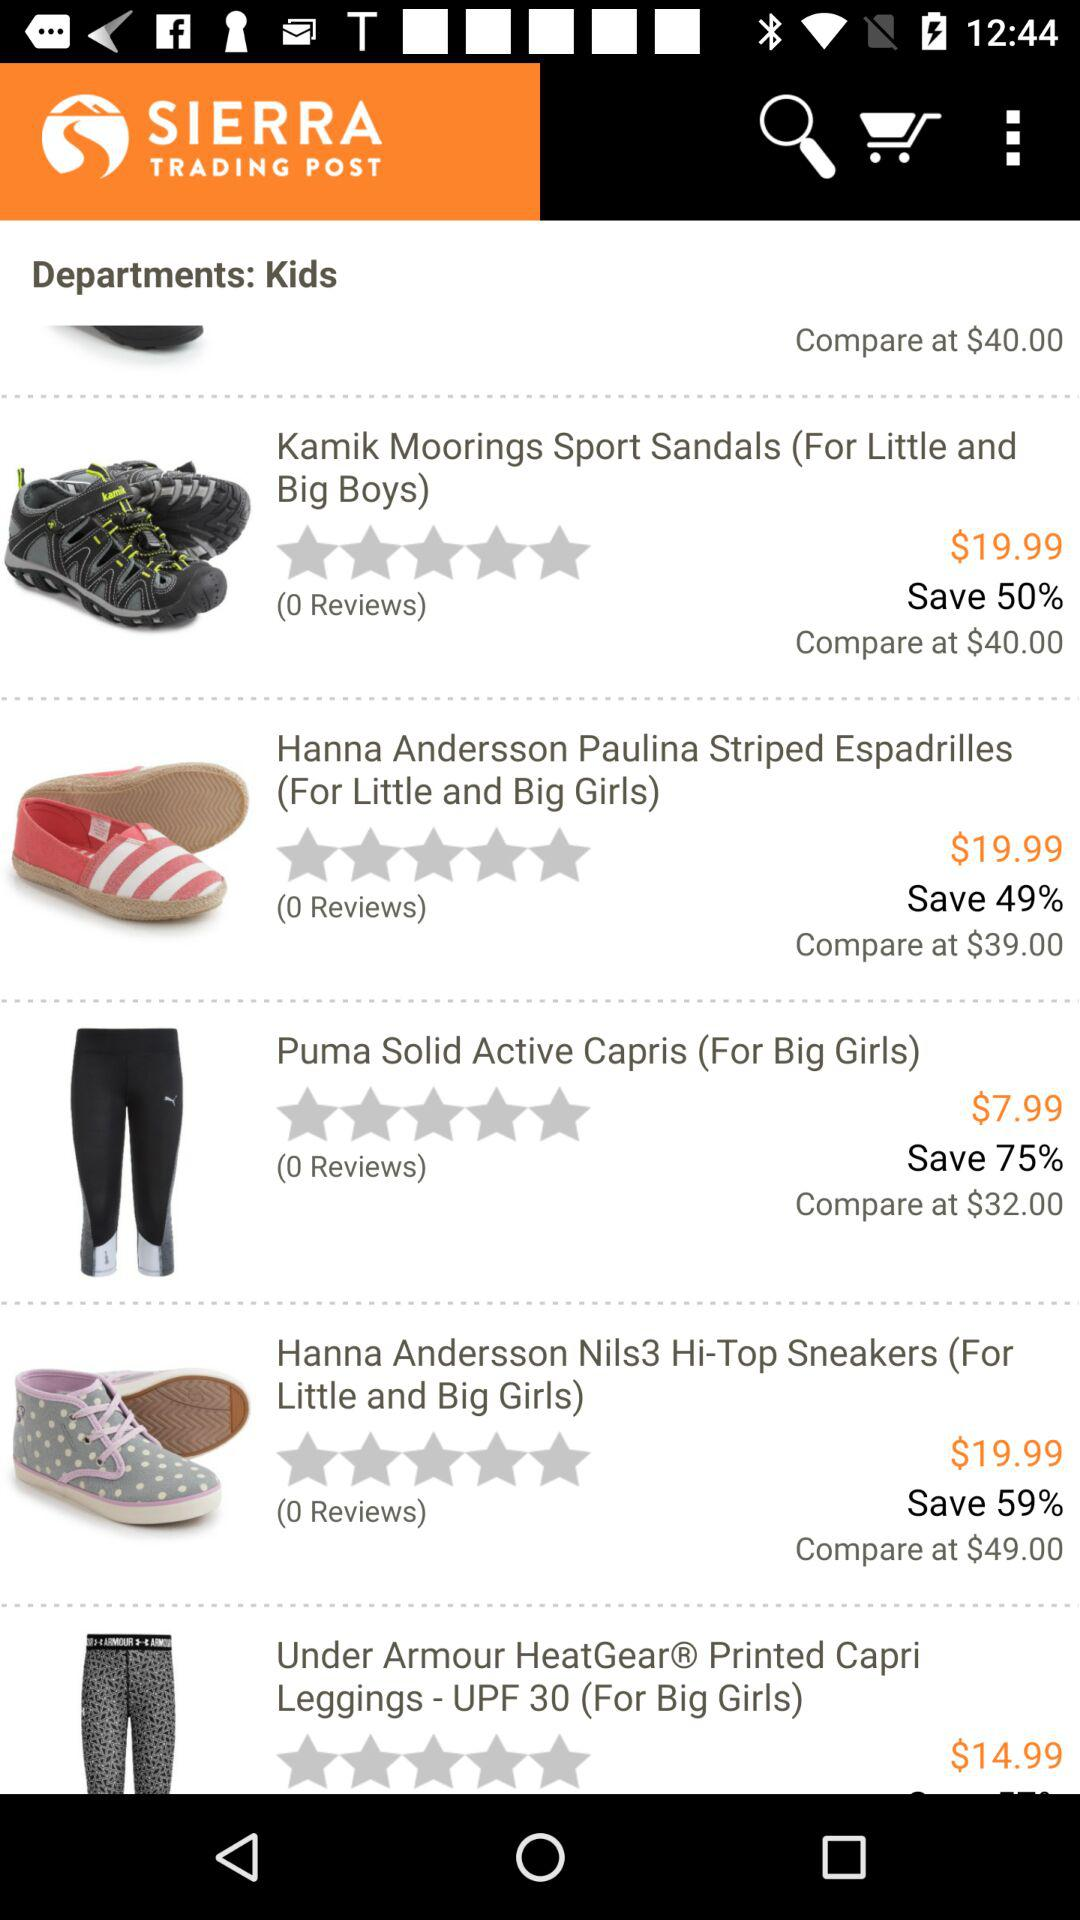What percent of a discount is available on "Kamik Moorings Sport Sandals"? A discount of 50% is available on "Kamik Moorings Sport Sandals". 